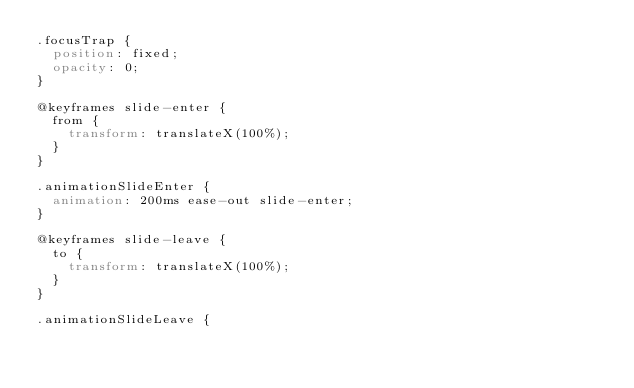Convert code to text. <code><loc_0><loc_0><loc_500><loc_500><_CSS_>.focusTrap {
  position: fixed;
  opacity: 0;
}

@keyframes slide-enter {
  from {
    transform: translateX(100%);
  }
}

.animationSlideEnter {
  animation: 200ms ease-out slide-enter;
}

@keyframes slide-leave {
  to {
    transform: translateX(100%);
  }
}

.animationSlideLeave {</code> 